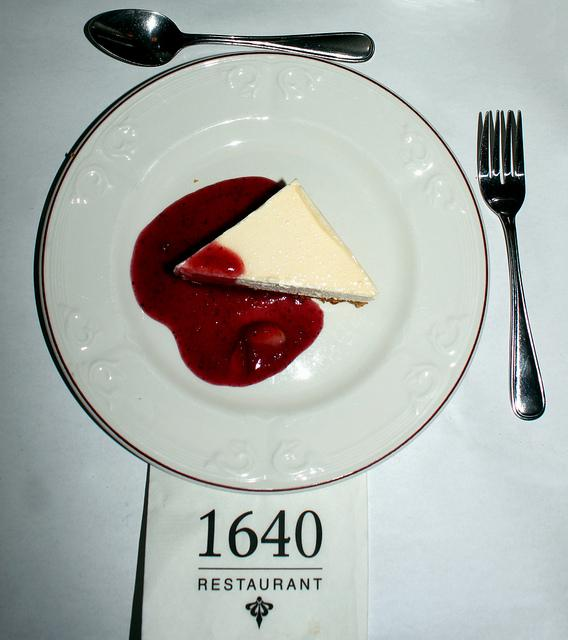What is on the plate? Please explain your reasoning. cake. It is a popular dessert made with cream cheese. 